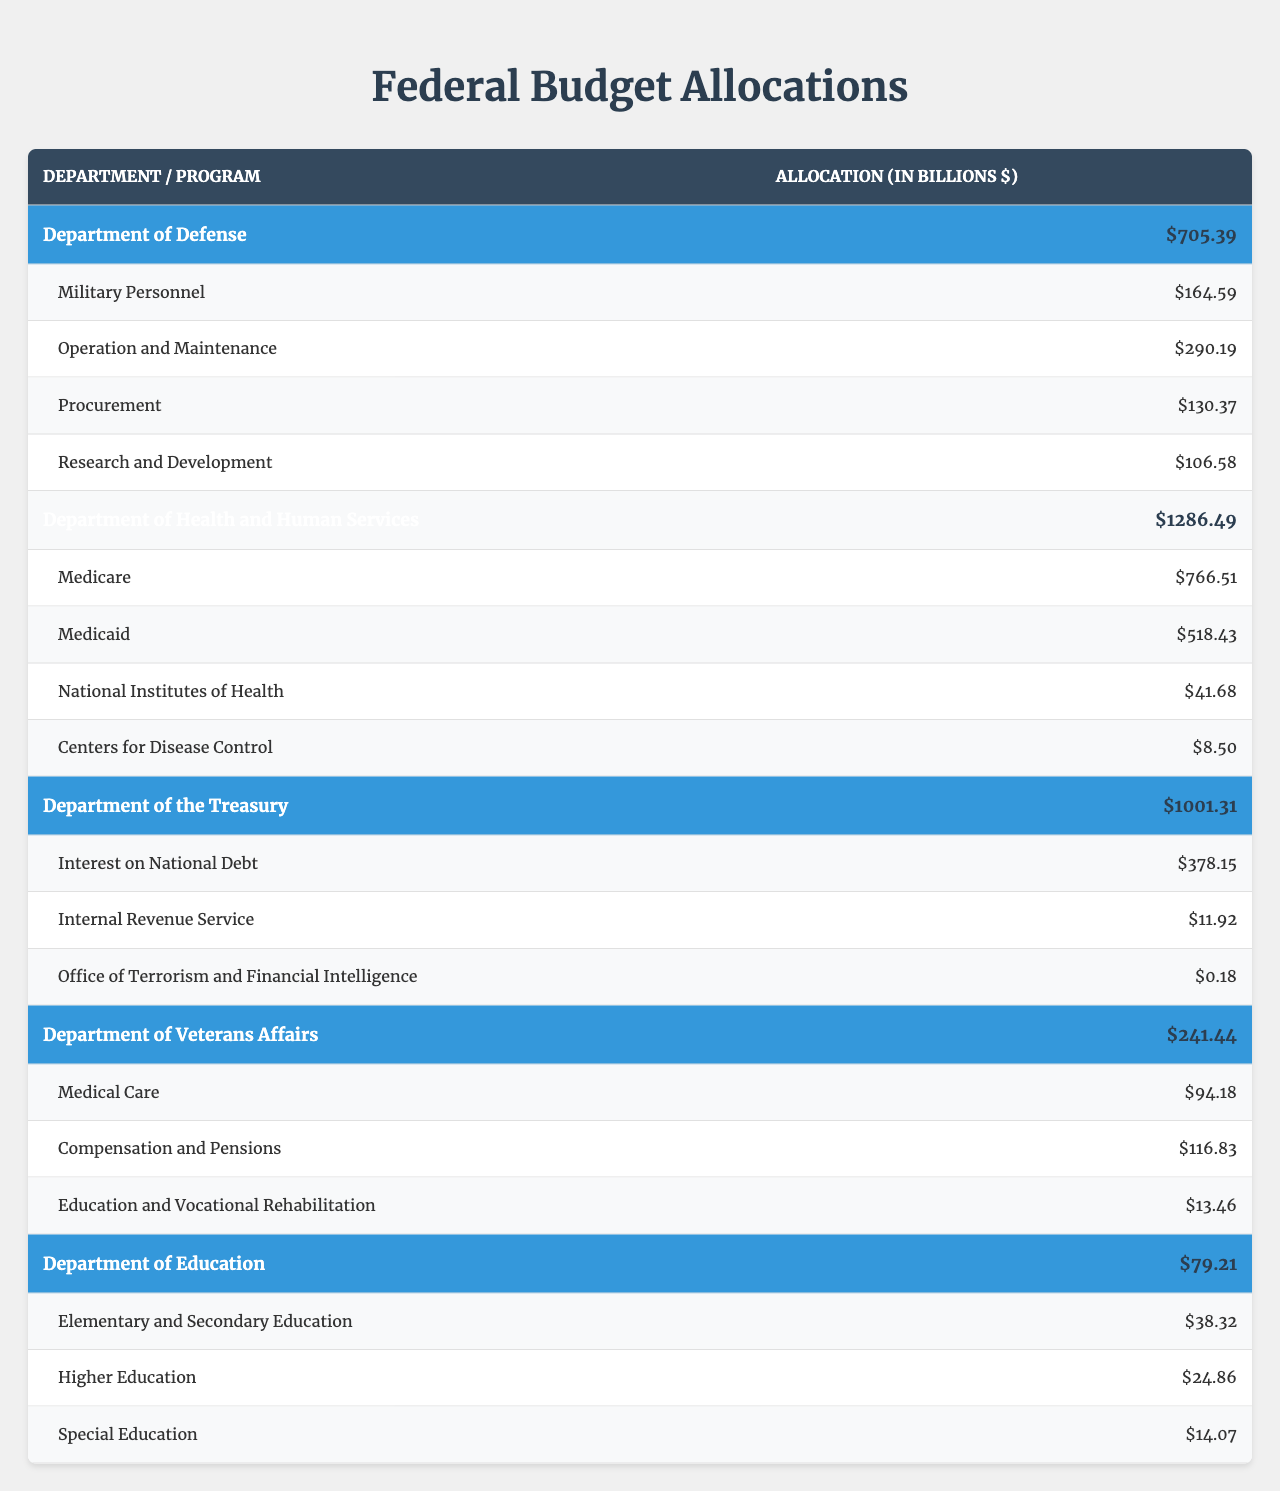What is the total budget allocated to the Department of Health and Human Services? You can find the total budget for each department in the table. For the Department of Health and Human Services, the total budget is stated as $1286.49 billion.
Answer: $1286.49 billion Which program under the Department of Defense has the highest allocation? The allocations for each program under the Department of Defense are listed. Military Personnel has $164.59 billion, Operation and Maintenance has $290.19 billion, Procurement has $130.37 billion, and Research and Development has $106.58 billion. Therefore, Operation and Maintenance has the highest allocation.
Answer: Operation and Maintenance What is the total allocation for Medicare and Medicaid combined? You will add the allocations of Medicare and Medicaid listed under the Department of Health and Human Services. Medicare is $766.51 billion and Medicaid is $518.43 billion. Summing these yields $766.51 + $518.43 = $1284.94 billion.
Answer: $1284.94 billion Is the total budget for the Department of Education greater than that of the Department of Veterans Affairs? The total budget for the Department of Education is $79.21 billion, while for the Department of Veterans Affairs it is $241.44 billion. Comparing these values shows that the Department of Education's budget is less than that of Veterans Affairs.
Answer: No What is the percentage of the total budget allocated to Research and Development compared to the total budget of the Department of Defense? Research and Development has an allocation of $106.58 billion, and the total budget for the Department of Defense is $705.39 billion. To find the percentage, divide $106.58 by $705.39 and multiply by 100: ($106.58 / $705.39) * 100 ≈ 15.1%.
Answer: Approximately 15.1% Which department has the smallest total budget, and what is that budget? By comparing the total budgets listed for all departments, the smallest total budget is for the Department of Education at $79.21 billion.
Answer: Department of Education; $79.21 billion How much is allocated to Compensation and Pensions in the Department of Veterans Affairs? The specific programs under the Department of Veterans Affairs include Compensation and Pensions, which has an allocation of $116.83 billion.
Answer: $116.83 billion What is the difference in total budget between the Department of the Treasury and the Department of Health and Human Services? To find the difference, subtract the total budget of the Department of the Treasury ($1001.31 billion) from that of Health and Human Services ($1286.49 billion): $1286.49 - $1001.31 = $285.18 billion.
Answer: $285.18 billion If the total allocation for Interest on National Debt is $378.15 billion, what fraction of the Department of the Treasury's total budget does this represent? The total budget for the Department of the Treasury is $1001.31 billion. The fraction of the budget that goes to Interest on National Debt is $378.15 / $1001.31. Simplifying this gives approximately 0.377, which translates to roughly 37.7% of the total budget.
Answer: Approximately 37.7% Are the combined allocations for Elementary and Secondary Education and Higher Education less than the total budget of the Department of Education? The allocations for Elementary and Secondary Education ($38.32 billion) and Higher Education ($24.86 billion) sum to $38.32 + $24.86 = $63.18 billion. The total budget for the Department of Education is $79.21 billion. Since $63.18 billion < $79.21 billion, the statement is true.
Answer: Yes 